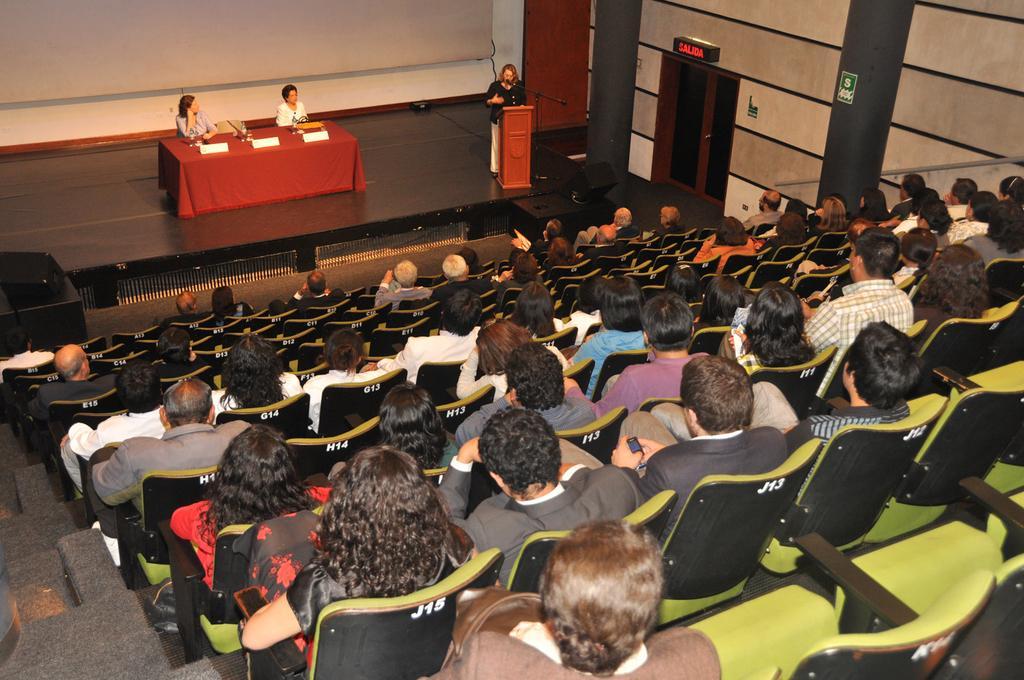How would you summarize this image in a sentence or two? In this image there are some persons sitting on the chairs as we can see in middle right side of this image, and there is a stage at top of this image and there is a table which is covered by a red color cloth at top of this image and there are two womens are sitting at left side of this image and one women is standing at right side of the image is wearing black color dress and there is a wall in the background and there is a door at top right side of this image. 